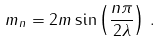Convert formula to latex. <formula><loc_0><loc_0><loc_500><loc_500>m _ { n } = 2 m \sin \left ( \frac { n \pi } { 2 \lambda } \right ) \, .</formula> 